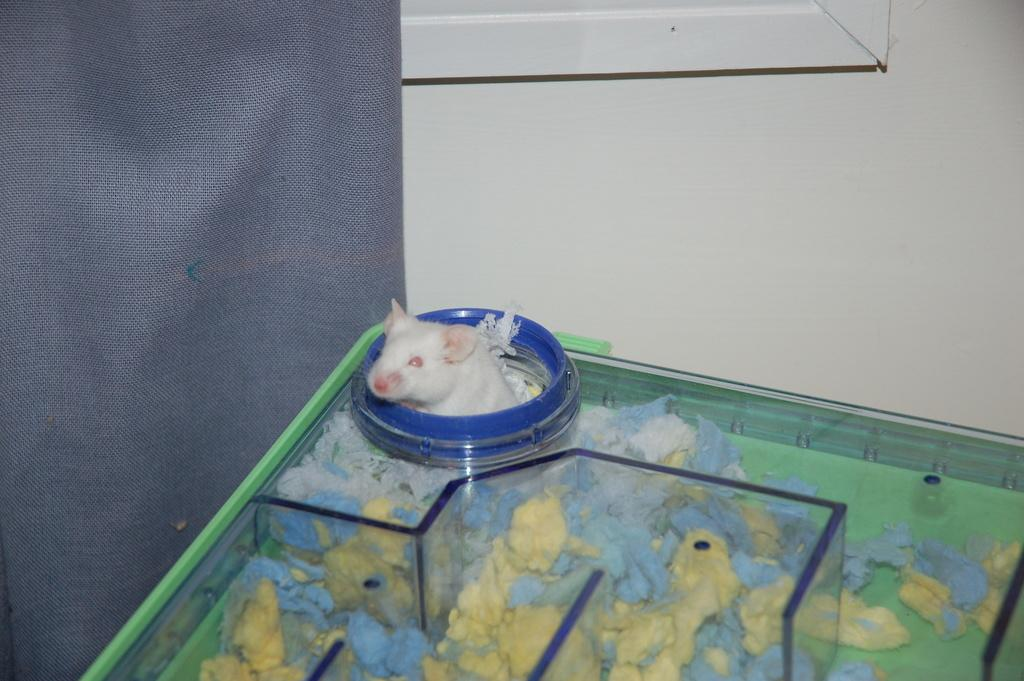What is located at the bottom of the image? There is a table at the bottom of the image. What is on the table in the image? There is a rat on the table. What is visible behind the table in the image? There is a wall behind the table. What type of fabric is present in the image? There is a cloth associated with the wall or table. What is the argument about between the rat and the wall in the image? There is no argument present in the image; it features a rat on a table with a wall in the background. Is there a bear visible in the image? No, there is no bear present in the image. 